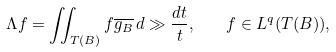<formula> <loc_0><loc_0><loc_500><loc_500>\Lambda f = \iint _ { T ( B ) } f \overline { g _ { B } } \, d \gg \frac { d t } { t } , \quad f \in L ^ { q } ( T ( B ) ) ,</formula> 